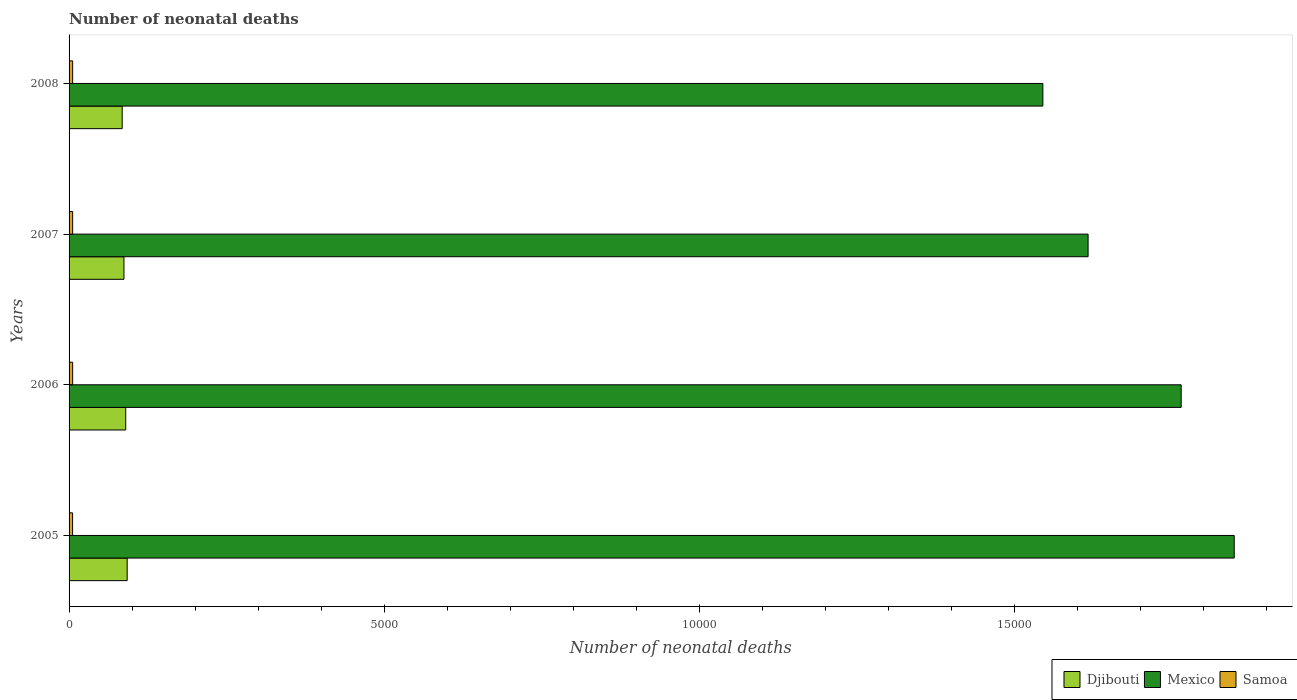How many different coloured bars are there?
Your answer should be very brief. 3. How many groups of bars are there?
Keep it short and to the point. 4. In how many cases, is the number of bars for a given year not equal to the number of legend labels?
Offer a very short reply. 0. What is the number of neonatal deaths in in Samoa in 2007?
Your response must be concise. 57. Across all years, what is the maximum number of neonatal deaths in in Samoa?
Ensure brevity in your answer.  57. Across all years, what is the minimum number of neonatal deaths in in Djibouti?
Your answer should be very brief. 843. What is the total number of neonatal deaths in in Mexico in the graph?
Give a very brief answer. 6.78e+04. What is the difference between the number of neonatal deaths in in Djibouti in 2006 and that in 2007?
Offer a very short reply. 28. What is the difference between the number of neonatal deaths in in Samoa in 2005 and the number of neonatal deaths in in Mexico in 2007?
Offer a terse response. -1.61e+04. What is the average number of neonatal deaths in in Mexico per year?
Your response must be concise. 1.69e+04. In the year 2008, what is the difference between the number of neonatal deaths in in Mexico and number of neonatal deaths in in Djibouti?
Give a very brief answer. 1.46e+04. What is the ratio of the number of neonatal deaths in in Mexico in 2006 to that in 2007?
Give a very brief answer. 1.09. What is the difference between the highest and the second highest number of neonatal deaths in in Samoa?
Ensure brevity in your answer.  0. What is the difference between the highest and the lowest number of neonatal deaths in in Mexico?
Offer a very short reply. 3037. In how many years, is the number of neonatal deaths in in Mexico greater than the average number of neonatal deaths in in Mexico taken over all years?
Provide a succinct answer. 2. What does the 3rd bar from the top in 2007 represents?
Your answer should be very brief. Djibouti. What does the 1st bar from the bottom in 2006 represents?
Make the answer very short. Djibouti. How many years are there in the graph?
Ensure brevity in your answer.  4. What is the difference between two consecutive major ticks on the X-axis?
Offer a terse response. 5000. Does the graph contain any zero values?
Ensure brevity in your answer.  No. How are the legend labels stacked?
Keep it short and to the point. Horizontal. What is the title of the graph?
Keep it short and to the point. Number of neonatal deaths. What is the label or title of the X-axis?
Your response must be concise. Number of neonatal deaths. What is the label or title of the Y-axis?
Your answer should be very brief. Years. What is the Number of neonatal deaths of Djibouti in 2005?
Keep it short and to the point. 922. What is the Number of neonatal deaths of Mexico in 2005?
Ensure brevity in your answer.  1.85e+04. What is the Number of neonatal deaths in Djibouti in 2006?
Your response must be concise. 899. What is the Number of neonatal deaths of Mexico in 2006?
Keep it short and to the point. 1.76e+04. What is the Number of neonatal deaths of Djibouti in 2007?
Offer a very short reply. 871. What is the Number of neonatal deaths in Mexico in 2007?
Your response must be concise. 1.62e+04. What is the Number of neonatal deaths of Djibouti in 2008?
Offer a terse response. 843. What is the Number of neonatal deaths in Mexico in 2008?
Offer a terse response. 1.55e+04. Across all years, what is the maximum Number of neonatal deaths in Djibouti?
Provide a succinct answer. 922. Across all years, what is the maximum Number of neonatal deaths in Mexico?
Make the answer very short. 1.85e+04. Across all years, what is the minimum Number of neonatal deaths of Djibouti?
Keep it short and to the point. 843. Across all years, what is the minimum Number of neonatal deaths of Mexico?
Offer a terse response. 1.55e+04. Across all years, what is the minimum Number of neonatal deaths in Samoa?
Offer a very short reply. 56. What is the total Number of neonatal deaths of Djibouti in the graph?
Offer a terse response. 3535. What is the total Number of neonatal deaths of Mexico in the graph?
Keep it short and to the point. 6.78e+04. What is the total Number of neonatal deaths of Samoa in the graph?
Ensure brevity in your answer.  227. What is the difference between the Number of neonatal deaths in Mexico in 2005 and that in 2006?
Provide a short and direct response. 842. What is the difference between the Number of neonatal deaths in Samoa in 2005 and that in 2006?
Provide a succinct answer. -1. What is the difference between the Number of neonatal deaths of Mexico in 2005 and that in 2007?
Offer a terse response. 2319. What is the difference between the Number of neonatal deaths in Djibouti in 2005 and that in 2008?
Give a very brief answer. 79. What is the difference between the Number of neonatal deaths in Mexico in 2005 and that in 2008?
Offer a terse response. 3037. What is the difference between the Number of neonatal deaths in Djibouti in 2006 and that in 2007?
Your response must be concise. 28. What is the difference between the Number of neonatal deaths in Mexico in 2006 and that in 2007?
Your answer should be very brief. 1477. What is the difference between the Number of neonatal deaths of Mexico in 2006 and that in 2008?
Your response must be concise. 2195. What is the difference between the Number of neonatal deaths in Mexico in 2007 and that in 2008?
Your response must be concise. 718. What is the difference between the Number of neonatal deaths in Djibouti in 2005 and the Number of neonatal deaths in Mexico in 2006?
Make the answer very short. -1.67e+04. What is the difference between the Number of neonatal deaths of Djibouti in 2005 and the Number of neonatal deaths of Samoa in 2006?
Provide a short and direct response. 865. What is the difference between the Number of neonatal deaths in Mexico in 2005 and the Number of neonatal deaths in Samoa in 2006?
Ensure brevity in your answer.  1.84e+04. What is the difference between the Number of neonatal deaths of Djibouti in 2005 and the Number of neonatal deaths of Mexico in 2007?
Your response must be concise. -1.52e+04. What is the difference between the Number of neonatal deaths of Djibouti in 2005 and the Number of neonatal deaths of Samoa in 2007?
Your response must be concise. 865. What is the difference between the Number of neonatal deaths of Mexico in 2005 and the Number of neonatal deaths of Samoa in 2007?
Keep it short and to the point. 1.84e+04. What is the difference between the Number of neonatal deaths in Djibouti in 2005 and the Number of neonatal deaths in Mexico in 2008?
Make the answer very short. -1.45e+04. What is the difference between the Number of neonatal deaths in Djibouti in 2005 and the Number of neonatal deaths in Samoa in 2008?
Provide a succinct answer. 865. What is the difference between the Number of neonatal deaths in Mexico in 2005 and the Number of neonatal deaths in Samoa in 2008?
Provide a succinct answer. 1.84e+04. What is the difference between the Number of neonatal deaths in Djibouti in 2006 and the Number of neonatal deaths in Mexico in 2007?
Make the answer very short. -1.53e+04. What is the difference between the Number of neonatal deaths of Djibouti in 2006 and the Number of neonatal deaths of Samoa in 2007?
Keep it short and to the point. 842. What is the difference between the Number of neonatal deaths in Mexico in 2006 and the Number of neonatal deaths in Samoa in 2007?
Keep it short and to the point. 1.76e+04. What is the difference between the Number of neonatal deaths of Djibouti in 2006 and the Number of neonatal deaths of Mexico in 2008?
Keep it short and to the point. -1.46e+04. What is the difference between the Number of neonatal deaths of Djibouti in 2006 and the Number of neonatal deaths of Samoa in 2008?
Provide a short and direct response. 842. What is the difference between the Number of neonatal deaths in Mexico in 2006 and the Number of neonatal deaths in Samoa in 2008?
Provide a short and direct response. 1.76e+04. What is the difference between the Number of neonatal deaths in Djibouti in 2007 and the Number of neonatal deaths in Mexico in 2008?
Offer a terse response. -1.46e+04. What is the difference between the Number of neonatal deaths of Djibouti in 2007 and the Number of neonatal deaths of Samoa in 2008?
Make the answer very short. 814. What is the difference between the Number of neonatal deaths in Mexico in 2007 and the Number of neonatal deaths in Samoa in 2008?
Ensure brevity in your answer.  1.61e+04. What is the average Number of neonatal deaths in Djibouti per year?
Offer a terse response. 883.75. What is the average Number of neonatal deaths in Mexico per year?
Give a very brief answer. 1.69e+04. What is the average Number of neonatal deaths of Samoa per year?
Offer a terse response. 56.75. In the year 2005, what is the difference between the Number of neonatal deaths in Djibouti and Number of neonatal deaths in Mexico?
Your response must be concise. -1.76e+04. In the year 2005, what is the difference between the Number of neonatal deaths in Djibouti and Number of neonatal deaths in Samoa?
Your answer should be compact. 866. In the year 2005, what is the difference between the Number of neonatal deaths in Mexico and Number of neonatal deaths in Samoa?
Make the answer very short. 1.84e+04. In the year 2006, what is the difference between the Number of neonatal deaths in Djibouti and Number of neonatal deaths in Mexico?
Make the answer very short. -1.67e+04. In the year 2006, what is the difference between the Number of neonatal deaths in Djibouti and Number of neonatal deaths in Samoa?
Offer a terse response. 842. In the year 2006, what is the difference between the Number of neonatal deaths in Mexico and Number of neonatal deaths in Samoa?
Your answer should be very brief. 1.76e+04. In the year 2007, what is the difference between the Number of neonatal deaths in Djibouti and Number of neonatal deaths in Mexico?
Make the answer very short. -1.53e+04. In the year 2007, what is the difference between the Number of neonatal deaths in Djibouti and Number of neonatal deaths in Samoa?
Your response must be concise. 814. In the year 2007, what is the difference between the Number of neonatal deaths in Mexico and Number of neonatal deaths in Samoa?
Provide a succinct answer. 1.61e+04. In the year 2008, what is the difference between the Number of neonatal deaths of Djibouti and Number of neonatal deaths of Mexico?
Make the answer very short. -1.46e+04. In the year 2008, what is the difference between the Number of neonatal deaths of Djibouti and Number of neonatal deaths of Samoa?
Provide a short and direct response. 786. In the year 2008, what is the difference between the Number of neonatal deaths of Mexico and Number of neonatal deaths of Samoa?
Offer a terse response. 1.54e+04. What is the ratio of the Number of neonatal deaths of Djibouti in 2005 to that in 2006?
Offer a terse response. 1.03. What is the ratio of the Number of neonatal deaths in Mexico in 2005 to that in 2006?
Keep it short and to the point. 1.05. What is the ratio of the Number of neonatal deaths of Samoa in 2005 to that in 2006?
Your answer should be very brief. 0.98. What is the ratio of the Number of neonatal deaths in Djibouti in 2005 to that in 2007?
Make the answer very short. 1.06. What is the ratio of the Number of neonatal deaths of Mexico in 2005 to that in 2007?
Your answer should be very brief. 1.14. What is the ratio of the Number of neonatal deaths in Samoa in 2005 to that in 2007?
Your answer should be very brief. 0.98. What is the ratio of the Number of neonatal deaths of Djibouti in 2005 to that in 2008?
Provide a succinct answer. 1.09. What is the ratio of the Number of neonatal deaths in Mexico in 2005 to that in 2008?
Provide a short and direct response. 1.2. What is the ratio of the Number of neonatal deaths of Samoa in 2005 to that in 2008?
Your response must be concise. 0.98. What is the ratio of the Number of neonatal deaths in Djibouti in 2006 to that in 2007?
Give a very brief answer. 1.03. What is the ratio of the Number of neonatal deaths in Mexico in 2006 to that in 2007?
Offer a terse response. 1.09. What is the ratio of the Number of neonatal deaths of Djibouti in 2006 to that in 2008?
Offer a terse response. 1.07. What is the ratio of the Number of neonatal deaths in Mexico in 2006 to that in 2008?
Your response must be concise. 1.14. What is the ratio of the Number of neonatal deaths of Djibouti in 2007 to that in 2008?
Provide a succinct answer. 1.03. What is the ratio of the Number of neonatal deaths in Mexico in 2007 to that in 2008?
Provide a short and direct response. 1.05. What is the difference between the highest and the second highest Number of neonatal deaths of Mexico?
Your response must be concise. 842. What is the difference between the highest and the second highest Number of neonatal deaths of Samoa?
Your response must be concise. 0. What is the difference between the highest and the lowest Number of neonatal deaths in Djibouti?
Offer a terse response. 79. What is the difference between the highest and the lowest Number of neonatal deaths of Mexico?
Offer a very short reply. 3037. What is the difference between the highest and the lowest Number of neonatal deaths in Samoa?
Give a very brief answer. 1. 